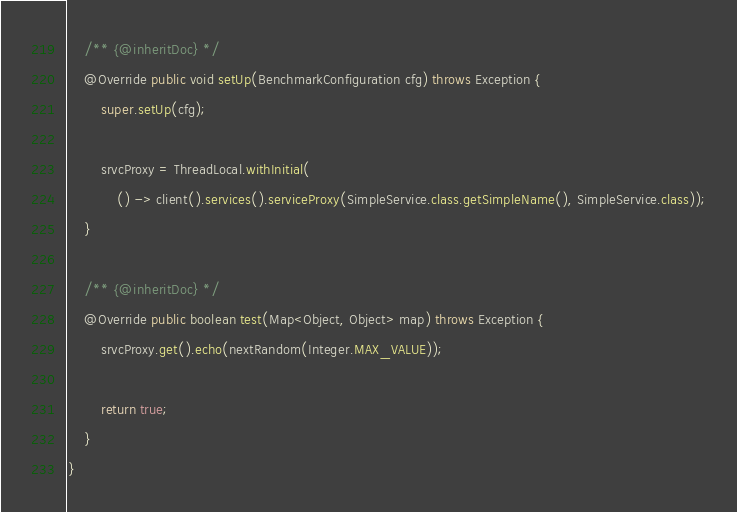<code> <loc_0><loc_0><loc_500><loc_500><_Java_>    /** {@inheritDoc} */
    @Override public void setUp(BenchmarkConfiguration cfg) throws Exception {
        super.setUp(cfg);

        srvcProxy = ThreadLocal.withInitial(
            () -> client().services().serviceProxy(SimpleService.class.getSimpleName(), SimpleService.class));
    }

    /** {@inheritDoc} */
    @Override public boolean test(Map<Object, Object> map) throws Exception {
        srvcProxy.get().echo(nextRandom(Integer.MAX_VALUE));

        return true;
    }
}
</code> 